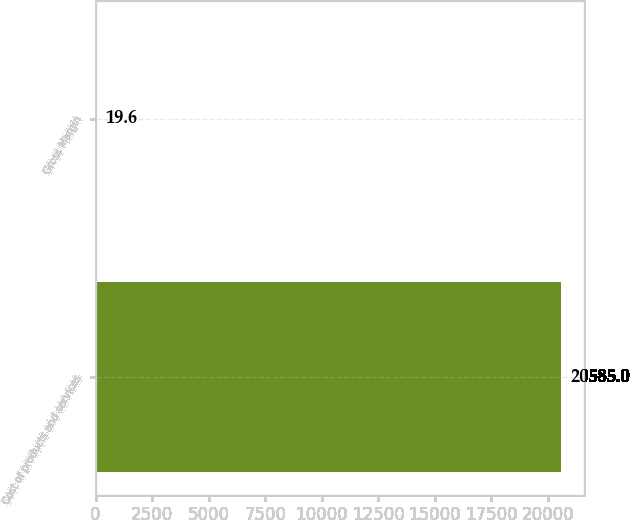Convert chart to OTSL. <chart><loc_0><loc_0><loc_500><loc_500><bar_chart><fcel>Cost of products and services<fcel>Gross Margin<nl><fcel>20585<fcel>19.6<nl></chart> 